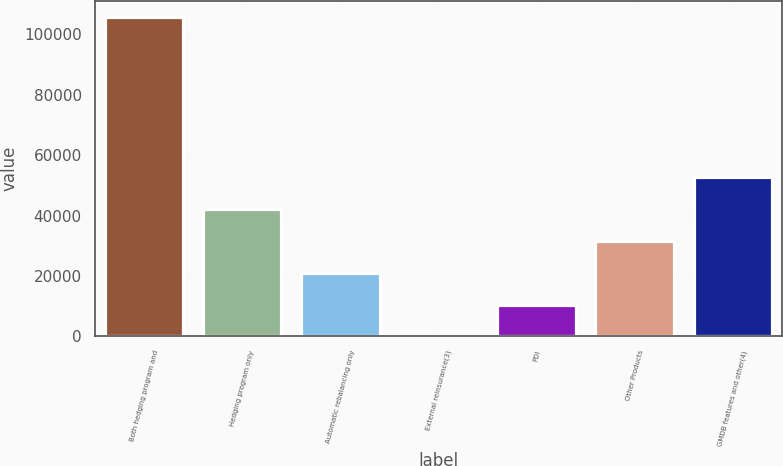<chart> <loc_0><loc_0><loc_500><loc_500><bar_chart><fcel>Both hedging program and<fcel>Hedging program only<fcel>Automatic rebalancing only<fcel>External reinsurance(3)<fcel>PDI<fcel>Other Products<fcel>GMDB features and other(4)<nl><fcel>105630<fcel>42252.1<fcel>21126.1<fcel>0.12<fcel>10563.1<fcel>31689.1<fcel>52815.1<nl></chart> 